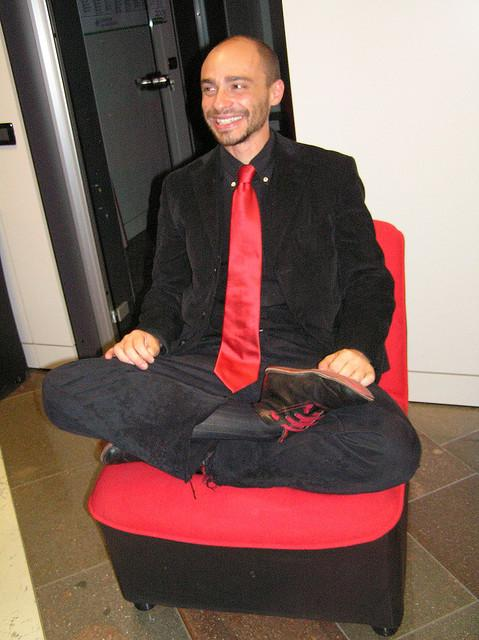What is the man wearing? tie 